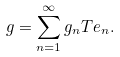Convert formula to latex. <formula><loc_0><loc_0><loc_500><loc_500>g = \sum _ { n = 1 } ^ { \infty } g _ { n } T e _ { n } .</formula> 